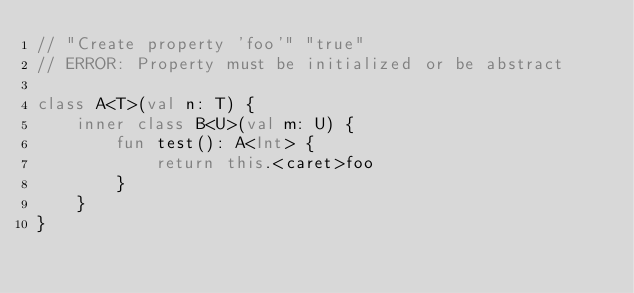Convert code to text. <code><loc_0><loc_0><loc_500><loc_500><_Kotlin_>// "Create property 'foo'" "true"
// ERROR: Property must be initialized or be abstract

class A<T>(val n: T) {
    inner class B<U>(val m: U) {
        fun test(): A<Int> {
            return this.<caret>foo
        }
    }
}
</code> 